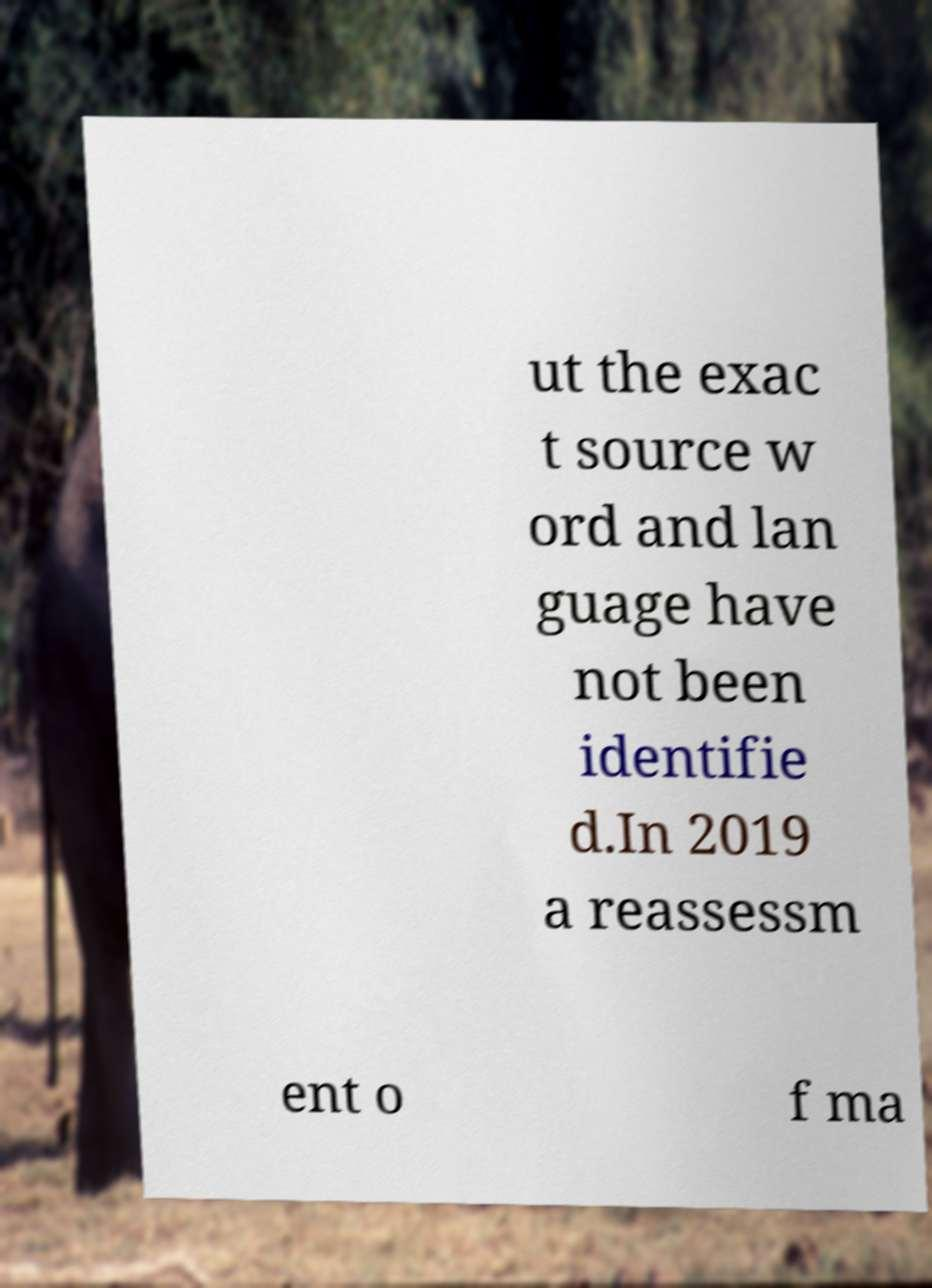What messages or text are displayed in this image? I need them in a readable, typed format. ut the exac t source w ord and lan guage have not been identifie d.In 2019 a reassessm ent o f ma 